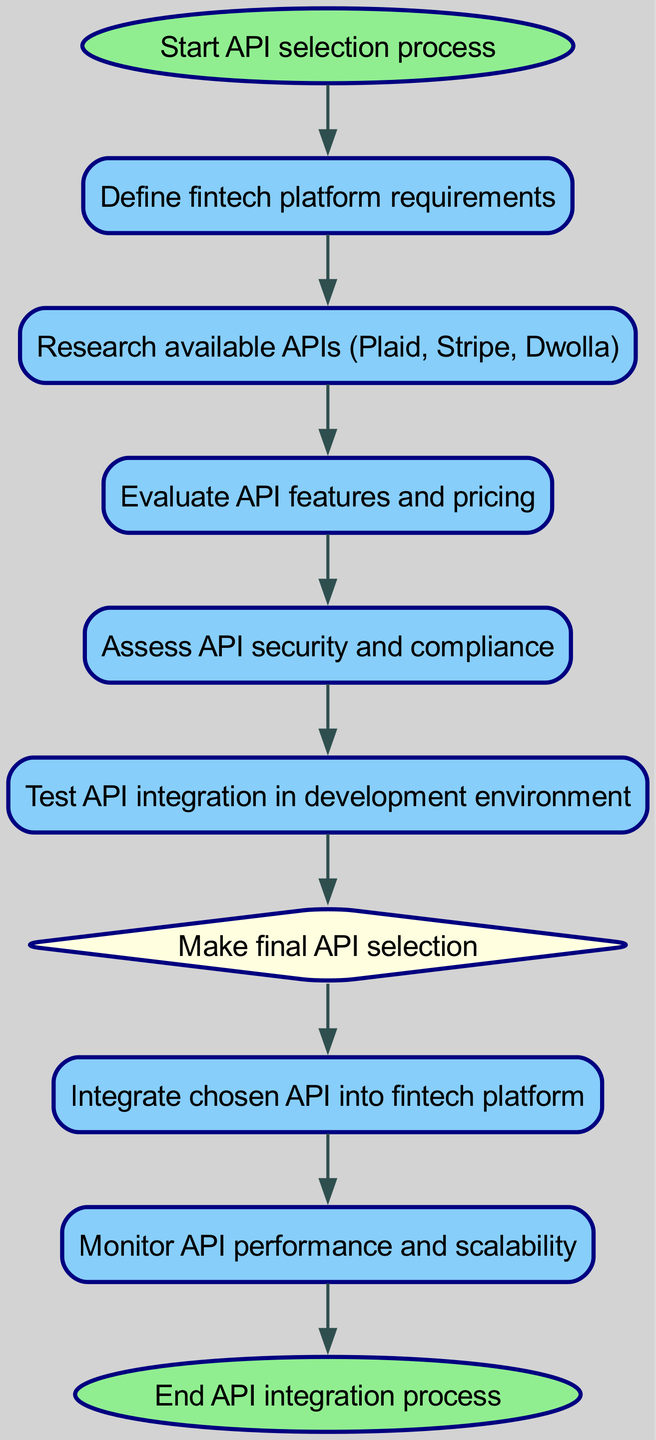What is the first step in the API selection process? The diagram indicates that the first step is "Start API selection process." This is represented as the initial node in the flowchart.
Answer: Start API selection process How many nodes are in the diagram? By counting each unique node outlined in the diagram, there are a total of 10 nodes. Each node represents a specific step in the process.
Answer: 10 What node follows the "Research available APIs" node? The flowchart shows that the node "Evaluate API features and pricing" directly follows "Research available APIs," indicating the progression in the selection process.
Answer: Evaluate API features and pricing What is the shape of the "Make final API selection" node? In the diagram, the "Make final API selection" node is shaped like a diamond, which typically signifies a decision point in programming flowcharts.
Answer: Diamond Which node is the last step in the integration process? By reviewing the diagram, the last node is "End API integration process," indicating the conclusion of the entire flowchart.
Answer: End API integration process What is the relationship between the "Assess API security and compliance" node and the "Make final API selection" node? The diagram shows a directed edge from "Assess API security and compliance" to "Make final API selection," which indicates this security assessment must be completed before a final decision can be made.
Answer: Direct edge What is the color of the nodes that represent decisions? In the diagram, decision nodes, such as "Make final API selection," are colored light yellow, distinguishing them from regular process nodes.
Answer: Light yellow Which node directly leads to "Integrate chosen API into fintech platform"? The "Make final API selection" node directly leads to the "Integrate chosen API into fintech platform" node, illustrating that integration follows the decision process.
Answer: Integrate chosen API into fintech platform What type of process is shown at the beginning of the diagram? The initial node, labeled "Start API selection process," indicates that the diagram represents a sequential process for selecting and integrating APIs.
Answer: Sequential process 